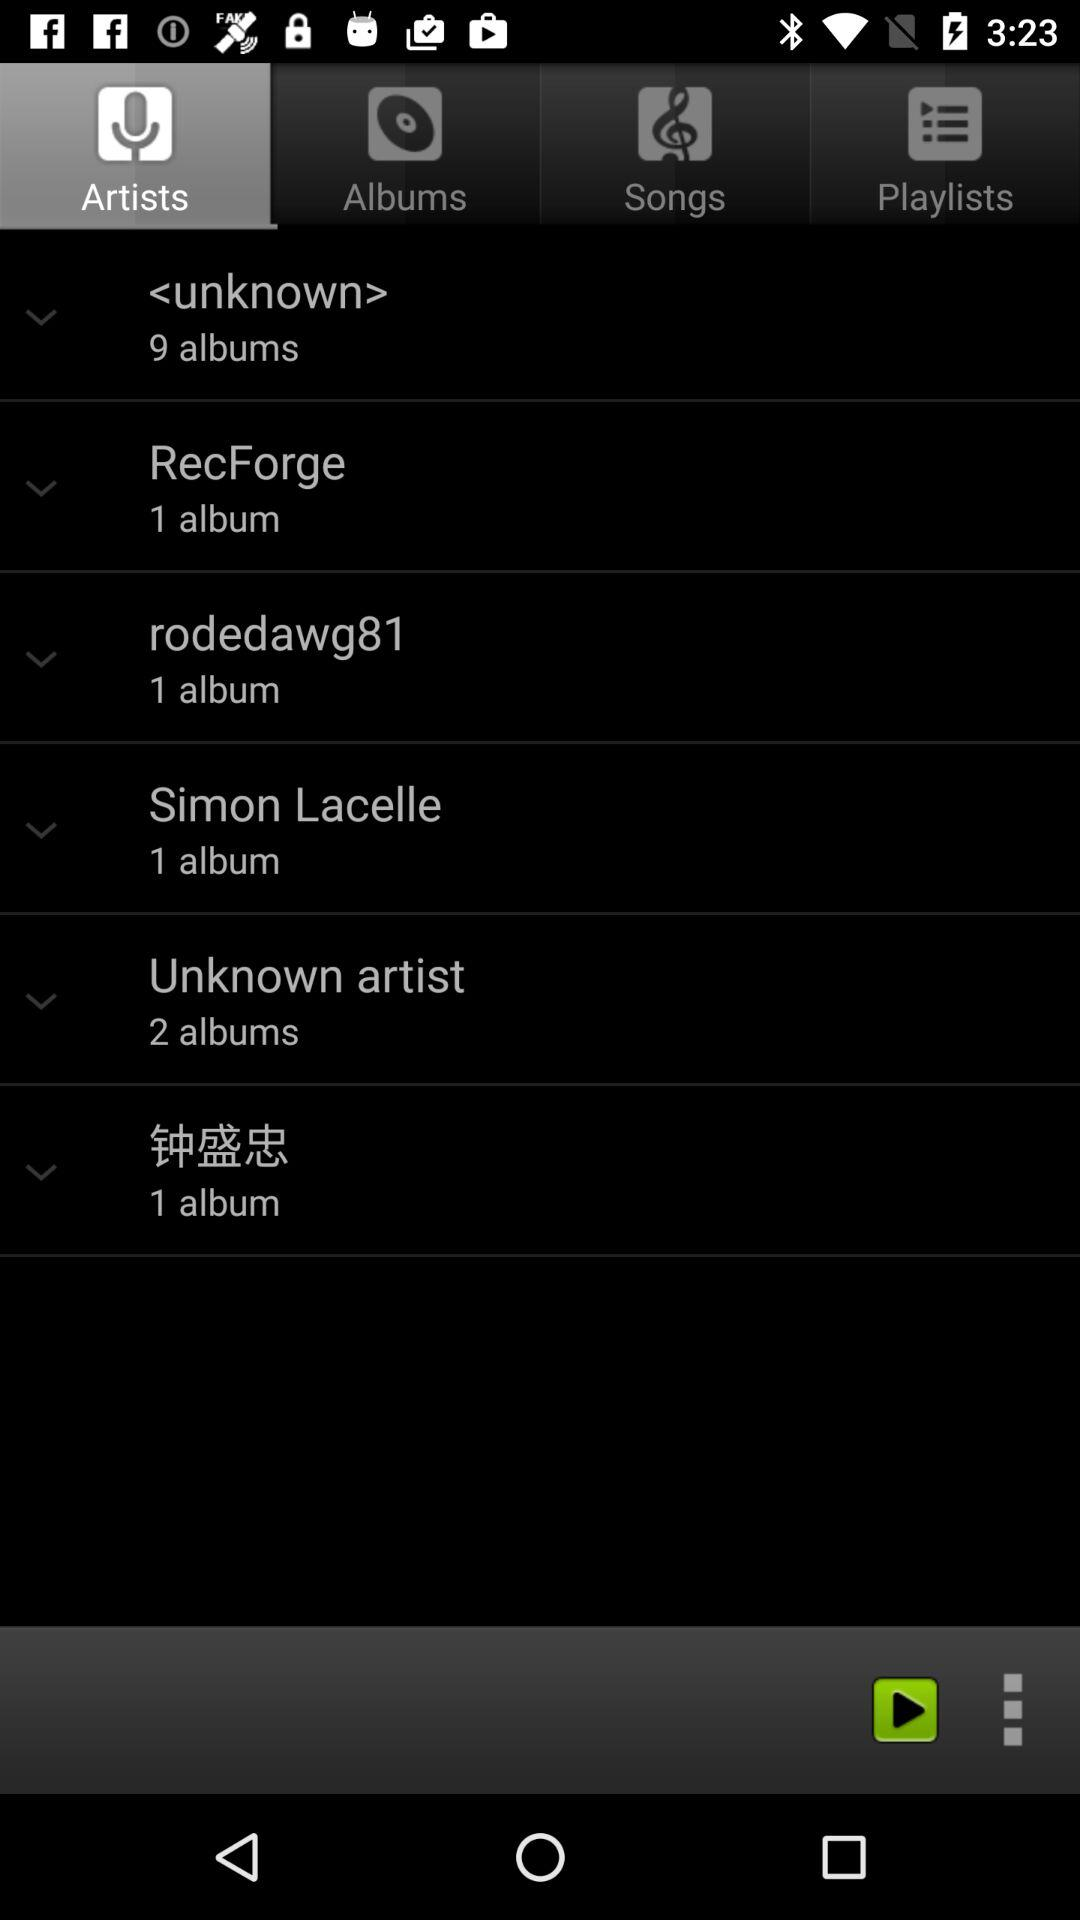How many more albums does the artist with the most albums have than the artist with the least?
Answer the question using a single word or phrase. 8 